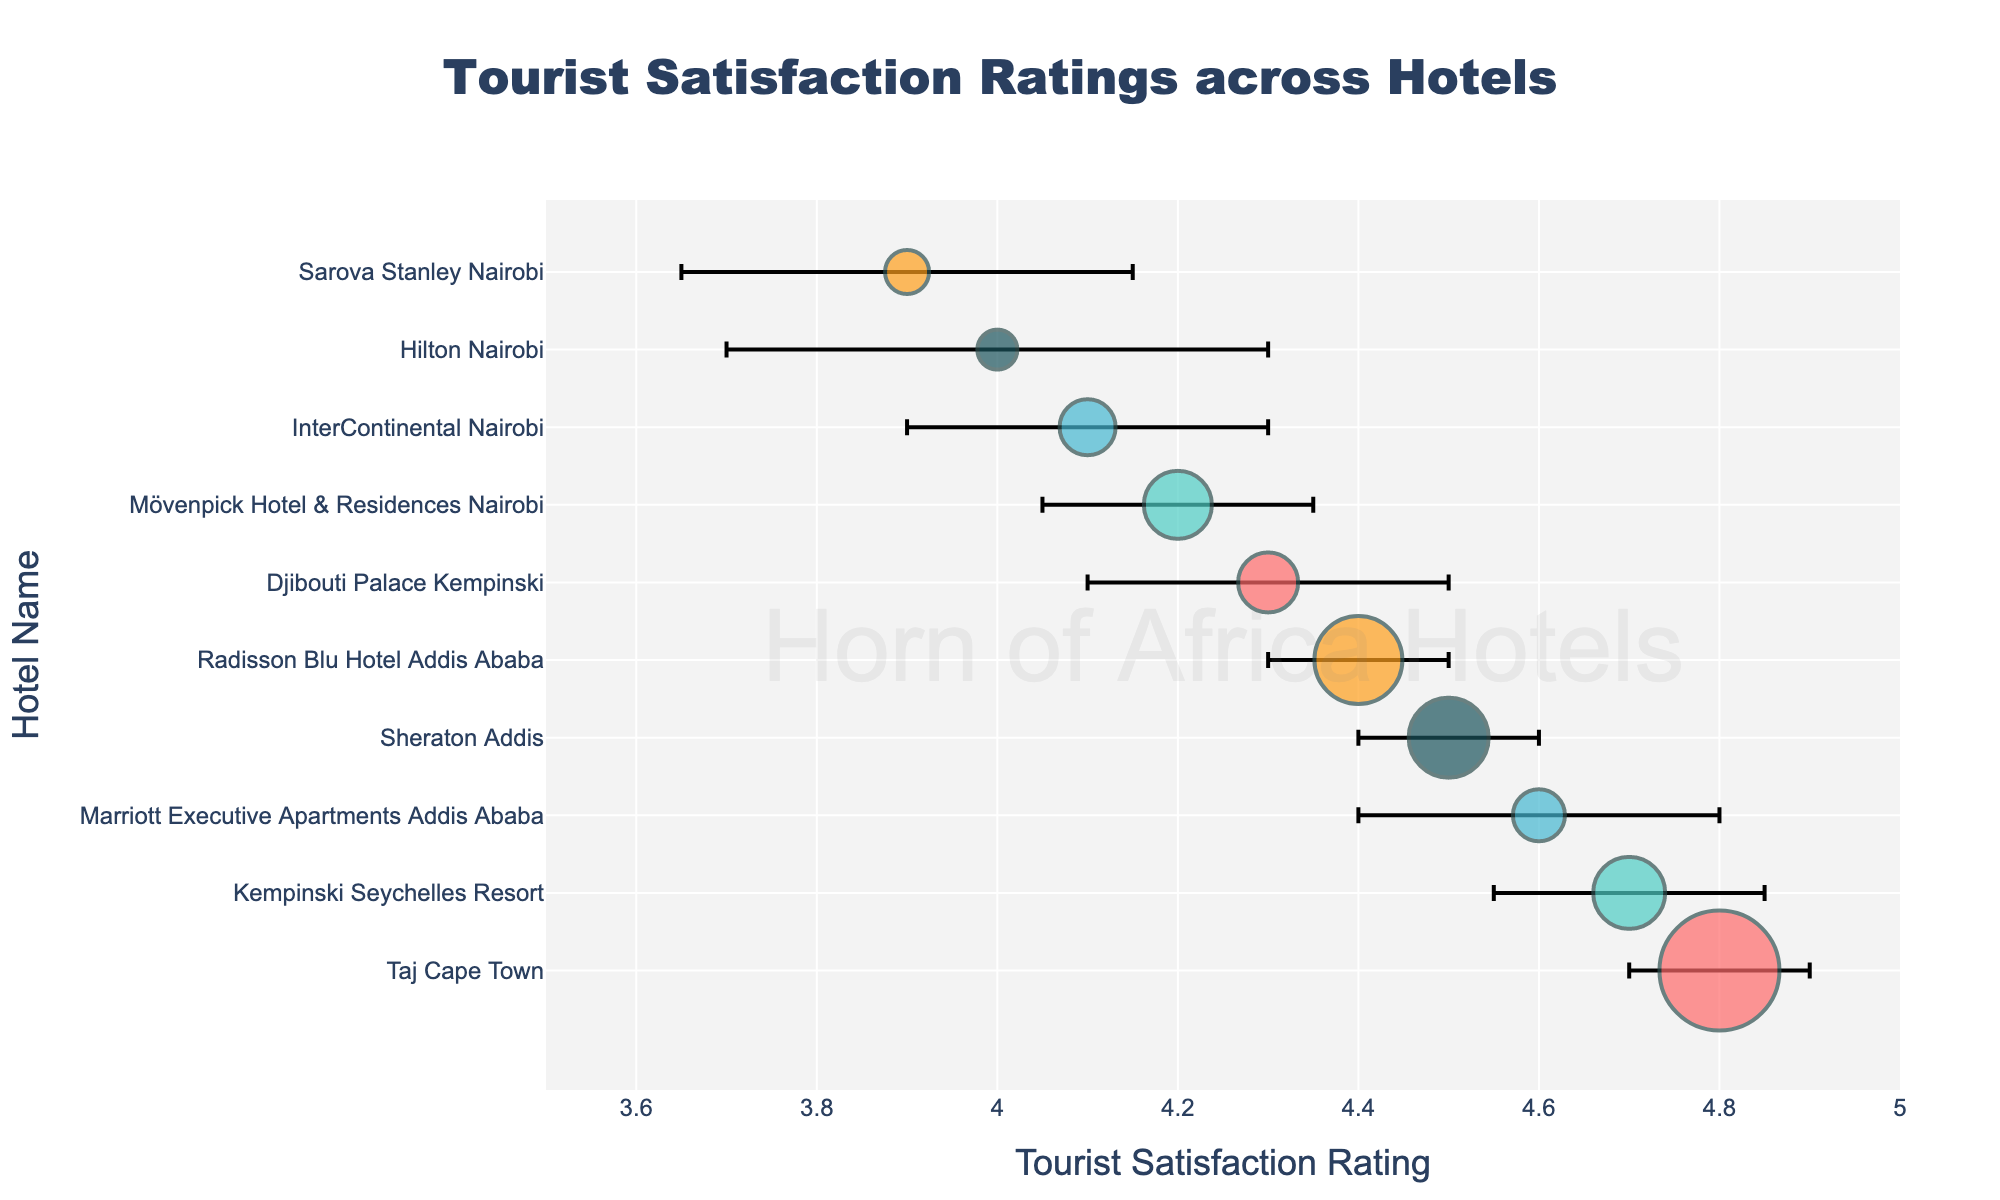What is the title of the plot? The title is located at the top center of the plot in larger font size, typically describing the overall content of the plot.
Answer: Tourist Satisfaction Ratings across Hotels Which hotel has the highest tourist satisfaction rating? Look for the highest value on the x-axis, and check which hotel it correlates with on the y-axis.
Answer: Taj Cape Town What is the lowest tourist satisfaction rating, and which hotel does it belong to? Identify the lowest value on the x-axis and find the hotel name on the y-axis associated with that value.
Answer: Sarova Stanley Nairobi at 3.9 What is the error margin for Sheraton Addis' satisfaction rating? Locate Sheraton Addis on the y-axis, then find the length of the error bar on the x-axis.
Answer: 0.1 Which hotel has the largest survey count? The size of the plot markers corresponds to the survey count; the largest marker represents the largest survey count.
Answer: Taj Cape Town What is the average tourist satisfaction rating of all the hotels displayed? Add all the satisfaction ratings and divide by the number of hotels shown.
Answer: (4.3 + 4.5 + 4.0 + 4.7 + 3.9 + 4.6 + 4.4 + 4.2 + 4.1 + 4.8) / 10 = 4.35 Compare the satisfaction ratings of Radisson Blu Hotel Addis Ababa and Mövenpick Hotel & Residences Nairobi. Which one is higher? Find both hotels on the y-axis, check their satisfaction ratings on the x-axis, and compare them.
Answer: Radisson Blu Hotel Addis Ababa (4.4) > Mövenpick Hotel & Residences Nairobi (4.2) Which hotel has the highest error margin, and what is the value? Identify the longest error bar on the x-axis and cross-check it with the y-axis to find the hotel name.
Answer: Hilton Nairobi with 0.3 Among the hotels located in Addis Ababa, which one has the highest tourist satisfaction rating? Compare tourist satisfaction ratings for Sheraton Addis, Marriott Executive Apartments Addis Ababa, and Radisson Blu Hotel Addis Ababa.
Answer: Sheraton Addis with 4.5 What is the average error margin of tourist satisfaction across all hotels? Sum all error margins and divide by the number of hotels.
Answer: (0.2 + 0.1 + 0.3 + 0.15 + 0.25 + 0.2 + 0.1 + 0.15 + 0.2 + 0.1) / 10 = 0.175 